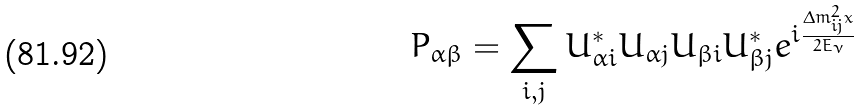Convert formula to latex. <formula><loc_0><loc_0><loc_500><loc_500>P _ { \alpha \beta } = \sum _ { i , j } U _ { \alpha i } ^ { * } U _ { \alpha j } U _ { \beta i } U _ { \beta j } ^ { * } e ^ { i \frac { \Delta m ^ { 2 } _ { i j } x } { 2 E _ { \nu } } }</formula> 